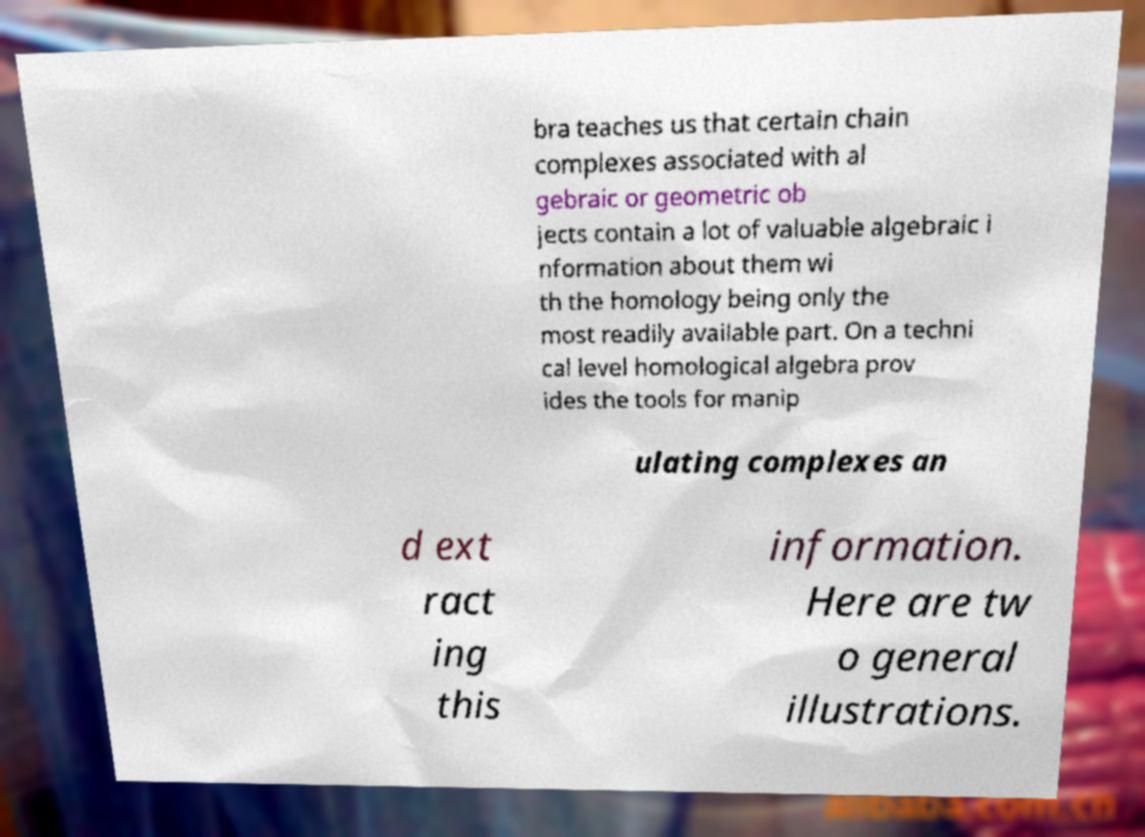Please read and relay the text visible in this image. What does it say? bra teaches us that certain chain complexes associated with al gebraic or geometric ob jects contain a lot of valuable algebraic i nformation about them wi th the homology being only the most readily available part. On a techni cal level homological algebra prov ides the tools for manip ulating complexes an d ext ract ing this information. Here are tw o general illustrations. 